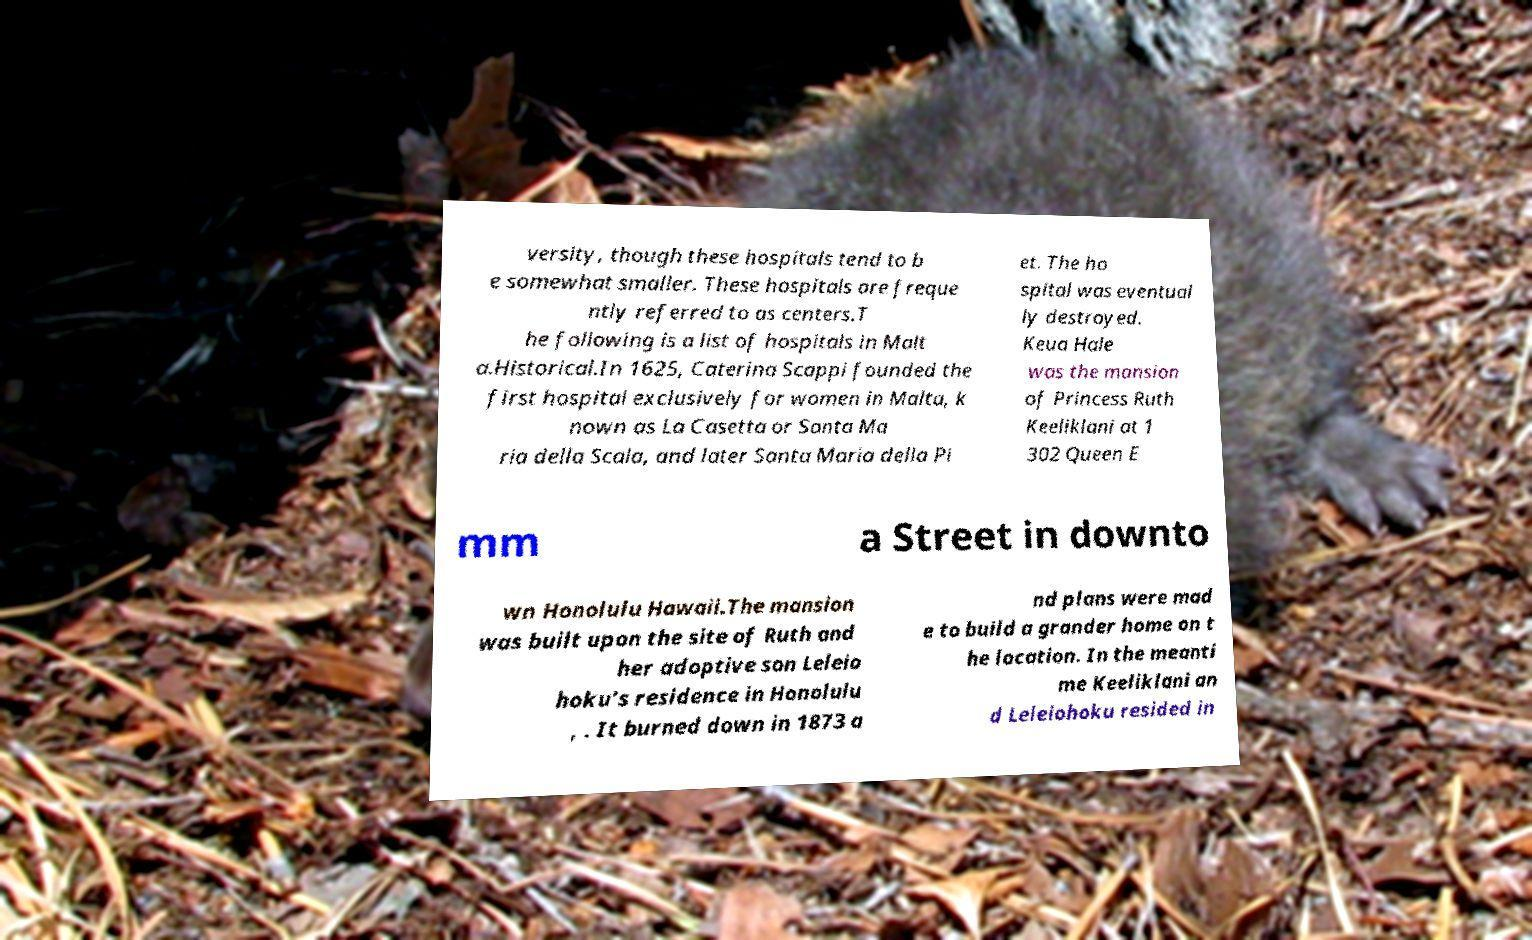Please identify and transcribe the text found in this image. versity, though these hospitals tend to b e somewhat smaller. These hospitals are freque ntly referred to as centers.T he following is a list of hospitals in Malt a.Historical.In 1625, Caterina Scappi founded the first hospital exclusively for women in Malta, k nown as La Casetta or Santa Ma ria della Scala, and later Santa Maria della Pi et. The ho spital was eventual ly destroyed. Keua Hale was the mansion of Princess Ruth Keeliklani at 1 302 Queen E mm a Street in downto wn Honolulu Hawaii.The mansion was built upon the site of Ruth and her adoptive son Leleio hoku's residence in Honolulu , . It burned down in 1873 a nd plans were mad e to build a grander home on t he location. In the meanti me Keeliklani an d Leleiohoku resided in 